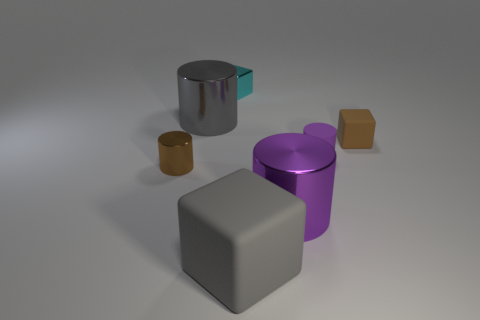Subtract 1 cylinders. How many cylinders are left? 3 Add 1 large gray cubes. How many objects exist? 8 Subtract all blocks. How many objects are left? 4 Add 1 small brown things. How many small brown things are left? 3 Add 3 brown metal things. How many brown metal things exist? 4 Subtract 1 gray cylinders. How many objects are left? 6 Subtract all big gray cylinders. Subtract all small purple things. How many objects are left? 5 